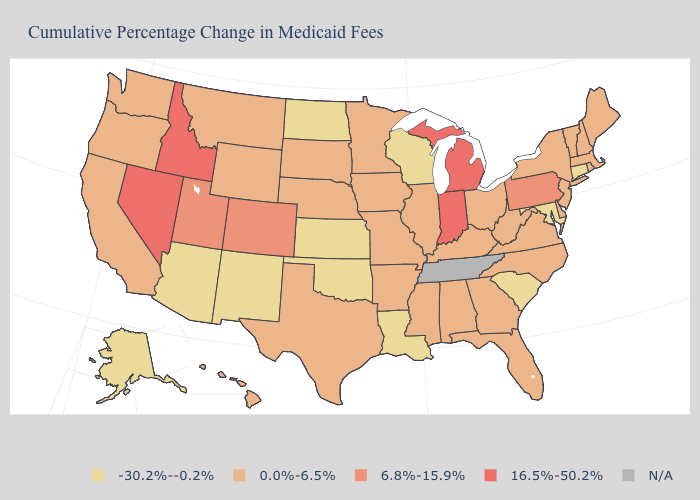What is the highest value in states that border South Dakota?
Keep it brief. 0.0%-6.5%. What is the value of Wisconsin?
Quick response, please. -30.2%--0.2%. Which states have the lowest value in the USA?
Be succinct. Alaska, Arizona, Connecticut, Kansas, Louisiana, Maryland, New Mexico, North Dakota, Oklahoma, South Carolina, Wisconsin. Name the states that have a value in the range 0.0%-6.5%?
Concise answer only. Alabama, Arkansas, California, Delaware, Florida, Georgia, Hawaii, Illinois, Iowa, Kentucky, Maine, Massachusetts, Minnesota, Mississippi, Missouri, Montana, Nebraska, New Hampshire, New Jersey, New York, North Carolina, Ohio, Oregon, Rhode Island, South Dakota, Texas, Vermont, Virginia, Washington, West Virginia, Wyoming. What is the lowest value in states that border Connecticut?
Give a very brief answer. 0.0%-6.5%. What is the value of Connecticut?
Concise answer only. -30.2%--0.2%. Name the states that have a value in the range 16.5%-50.2%?
Give a very brief answer. Idaho, Indiana, Michigan, Nevada. What is the value of Iowa?
Concise answer only. 0.0%-6.5%. Does the first symbol in the legend represent the smallest category?
Quick response, please. Yes. What is the highest value in states that border Oklahoma?
Be succinct. 6.8%-15.9%. Does Texas have the highest value in the USA?
Concise answer only. No. Name the states that have a value in the range -30.2%--0.2%?
Be succinct. Alaska, Arizona, Connecticut, Kansas, Louisiana, Maryland, New Mexico, North Dakota, Oklahoma, South Carolina, Wisconsin. What is the value of Nebraska?
Concise answer only. 0.0%-6.5%. Which states have the highest value in the USA?
Be succinct. Idaho, Indiana, Michigan, Nevada. What is the highest value in the Northeast ?
Write a very short answer. 6.8%-15.9%. 